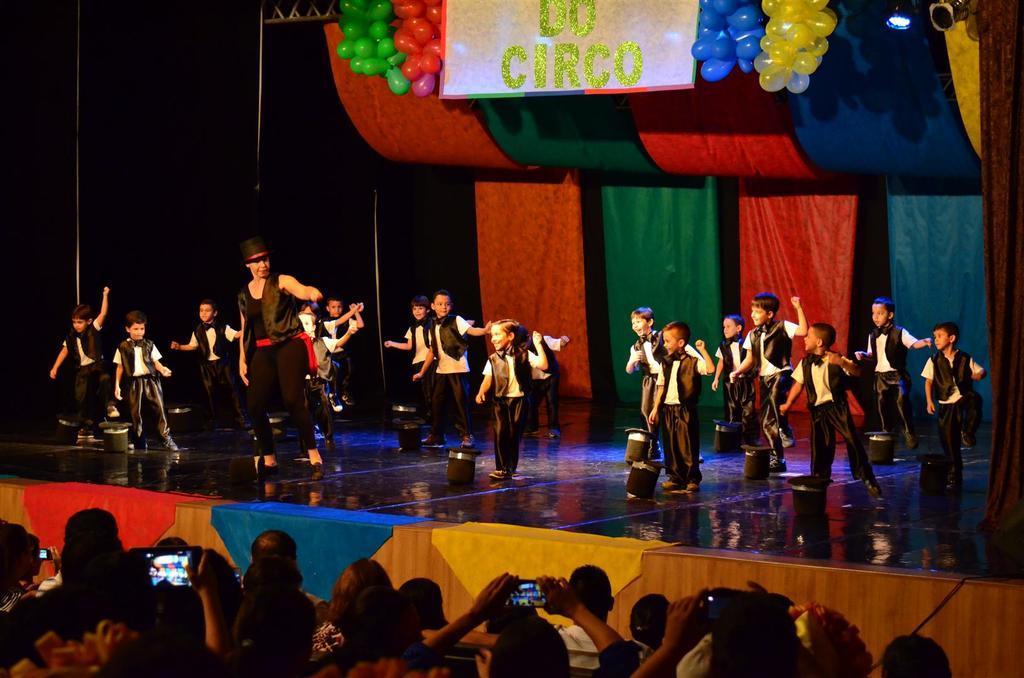In one or two sentences, can you explain what this image depicts? At the bottom of the image there are few people holding the mobiles in the hands. In front of them there is a stage and on the stage there are few colorful clothes on it. On the stage there are many kids and beside them there are hats. And also there is a person on the stage. Behind them there are colorful curtains. At the top of the image there is a board with something written on it. And also there are many balloons. 